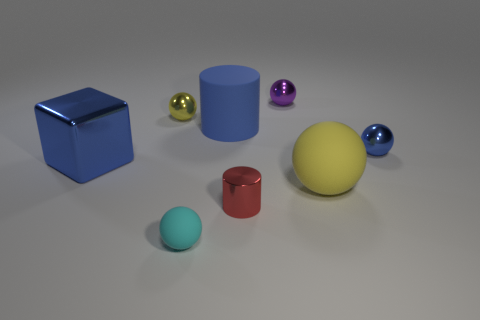Is there any other thing that is made of the same material as the blue cylinder?
Give a very brief answer. Yes. How big is the yellow sphere that is behind the large rubber sphere?
Provide a short and direct response. Small. There is a large matte object that is in front of the small shiny sphere on the right side of the small purple shiny thing; what number of large blue cylinders are behind it?
Your answer should be very brief. 1. What color is the tiny object that is to the left of the tiny matte thing in front of the tiny red shiny cylinder?
Keep it short and to the point. Yellow. Are there any cyan objects of the same size as the yellow rubber sphere?
Give a very brief answer. No. What material is the small thing that is behind the yellow object behind the tiny sphere that is on the right side of the large rubber ball made of?
Provide a short and direct response. Metal. What number of big blue cylinders are on the left side of the rubber ball on the left side of the large sphere?
Your response must be concise. 0. There is a rubber ball that is on the left side of the purple thing; is it the same size as the red thing?
Your answer should be compact. Yes. How many small red metallic things are the same shape as the large blue rubber thing?
Ensure brevity in your answer.  1. What is the shape of the big blue shiny thing?
Provide a short and direct response. Cube. 